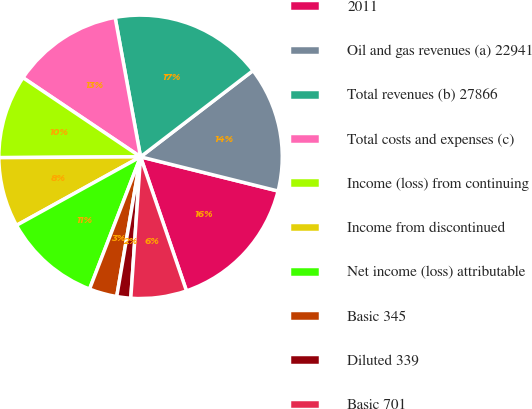Convert chart. <chart><loc_0><loc_0><loc_500><loc_500><pie_chart><fcel>2011<fcel>Oil and gas revenues (a) 22941<fcel>Total revenues (b) 27866<fcel>Total costs and expenses (c)<fcel>Income (loss) from continuing<fcel>Income from discontinued<fcel>Net income (loss) attributable<fcel>Basic 345<fcel>Diluted 339<fcel>Basic 701<nl><fcel>15.87%<fcel>14.29%<fcel>17.46%<fcel>12.7%<fcel>9.52%<fcel>7.94%<fcel>11.11%<fcel>3.17%<fcel>1.59%<fcel>6.35%<nl></chart> 